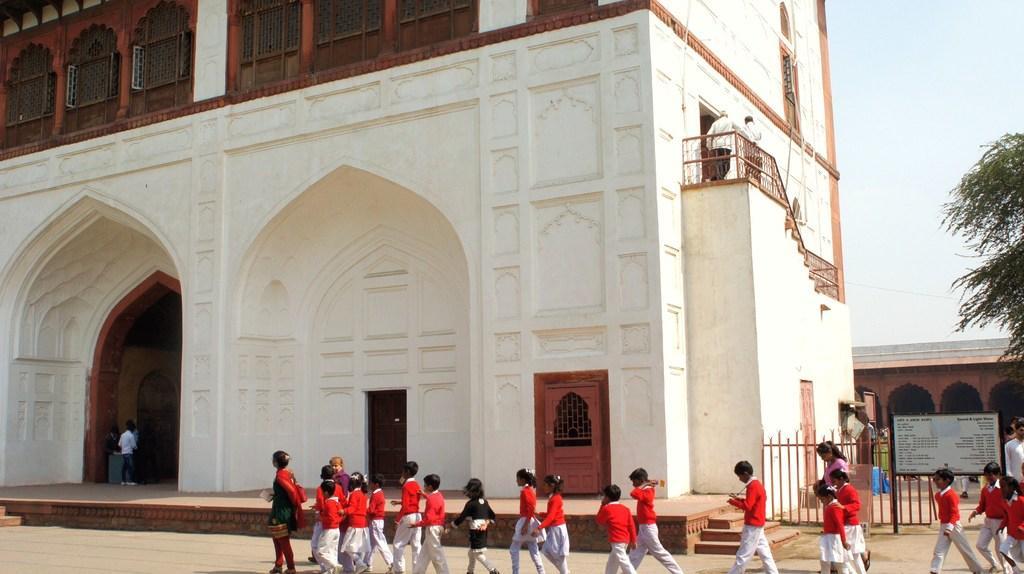In one or two sentences, can you explain what this image depicts? In this picture there are people and we can see building, railing and board on grille. On the right side of the image we can see leaves. In the background of the image we can see pillars, wall, board and sky. 